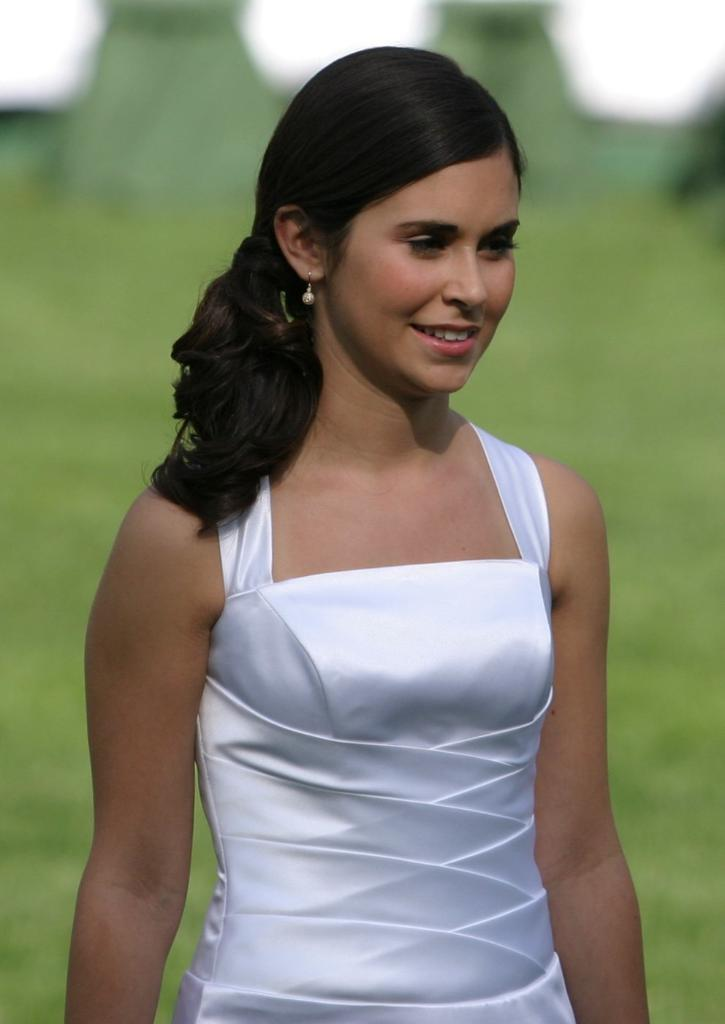Who is present in the image? There is a woman in the image. What is the woman's facial expression? The woman is smiling. What color is the background of the image? The background of the image is green. What type of sweater is the woman wearing in the image? There is no sweater visible in the image; the woman is not wearing any clothing. Can you describe the tub in the image? There is no tub present in the image. 